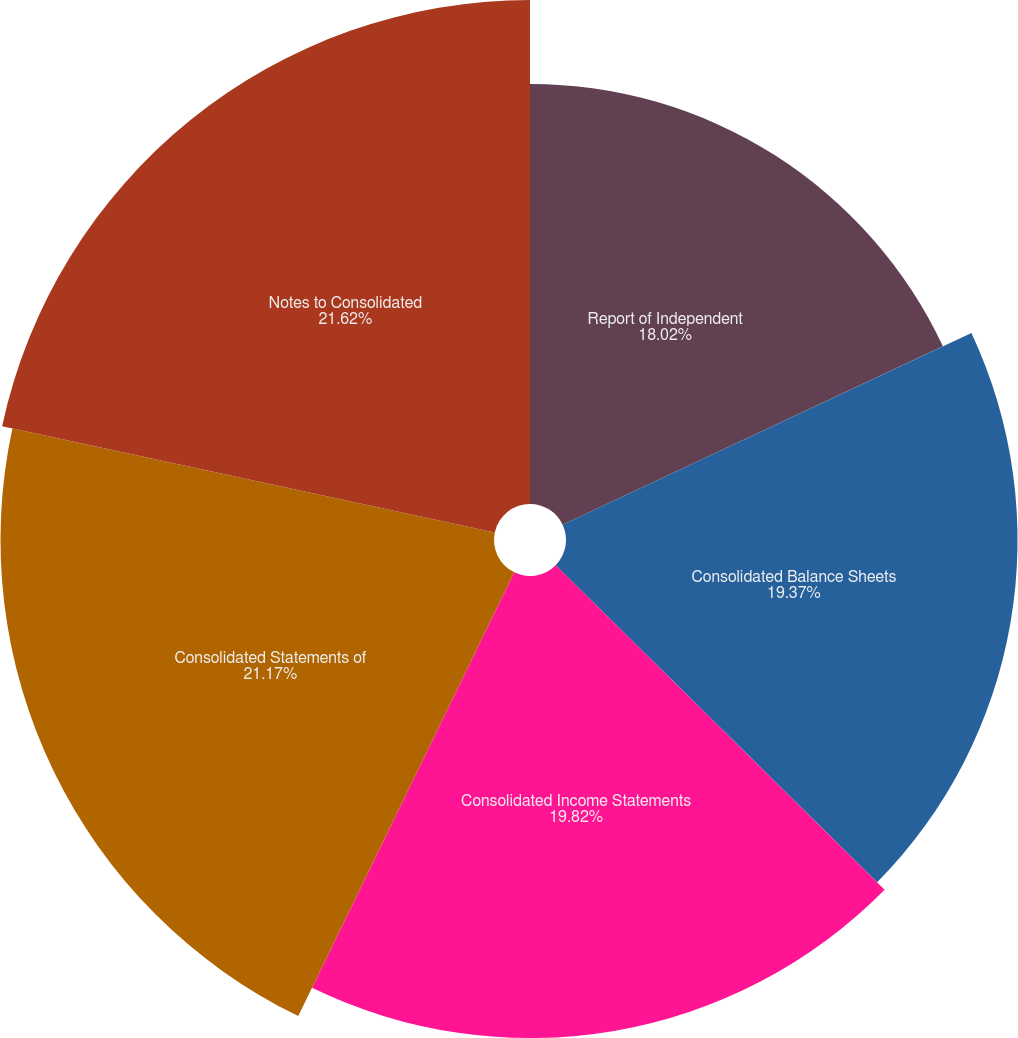Convert chart to OTSL. <chart><loc_0><loc_0><loc_500><loc_500><pie_chart><fcel>Report of Independent<fcel>Consolidated Balance Sheets<fcel>Consolidated Income Statements<fcel>Consolidated Statements of<fcel>Notes to Consolidated<nl><fcel>18.02%<fcel>19.37%<fcel>19.82%<fcel>21.17%<fcel>21.62%<nl></chart> 